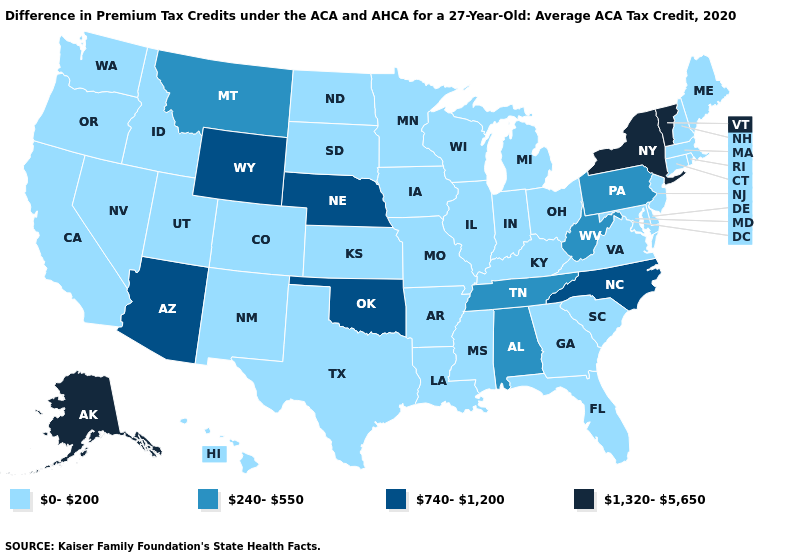What is the value of Wisconsin?
Concise answer only. 0-200. Which states have the lowest value in the USA?
Answer briefly. Arkansas, California, Colorado, Connecticut, Delaware, Florida, Georgia, Hawaii, Idaho, Illinois, Indiana, Iowa, Kansas, Kentucky, Louisiana, Maine, Maryland, Massachusetts, Michigan, Minnesota, Mississippi, Missouri, Nevada, New Hampshire, New Jersey, New Mexico, North Dakota, Ohio, Oregon, Rhode Island, South Carolina, South Dakota, Texas, Utah, Virginia, Washington, Wisconsin. Which states have the lowest value in the South?
Be succinct. Arkansas, Delaware, Florida, Georgia, Kentucky, Louisiana, Maryland, Mississippi, South Carolina, Texas, Virginia. Is the legend a continuous bar?
Write a very short answer. No. What is the value of New Jersey?
Answer briefly. 0-200. What is the highest value in the USA?
Write a very short answer. 1,320-5,650. Which states have the lowest value in the USA?
Keep it brief. Arkansas, California, Colorado, Connecticut, Delaware, Florida, Georgia, Hawaii, Idaho, Illinois, Indiana, Iowa, Kansas, Kentucky, Louisiana, Maine, Maryland, Massachusetts, Michigan, Minnesota, Mississippi, Missouri, Nevada, New Hampshire, New Jersey, New Mexico, North Dakota, Ohio, Oregon, Rhode Island, South Carolina, South Dakota, Texas, Utah, Virginia, Washington, Wisconsin. Does the map have missing data?
Be succinct. No. What is the highest value in the South ?
Short answer required. 740-1,200. What is the value of South Dakota?
Answer briefly. 0-200. What is the value of Alabama?
Concise answer only. 240-550. Is the legend a continuous bar?
Be succinct. No. Does Ohio have the lowest value in the MidWest?
Be succinct. Yes. What is the lowest value in the USA?
Give a very brief answer. 0-200. 